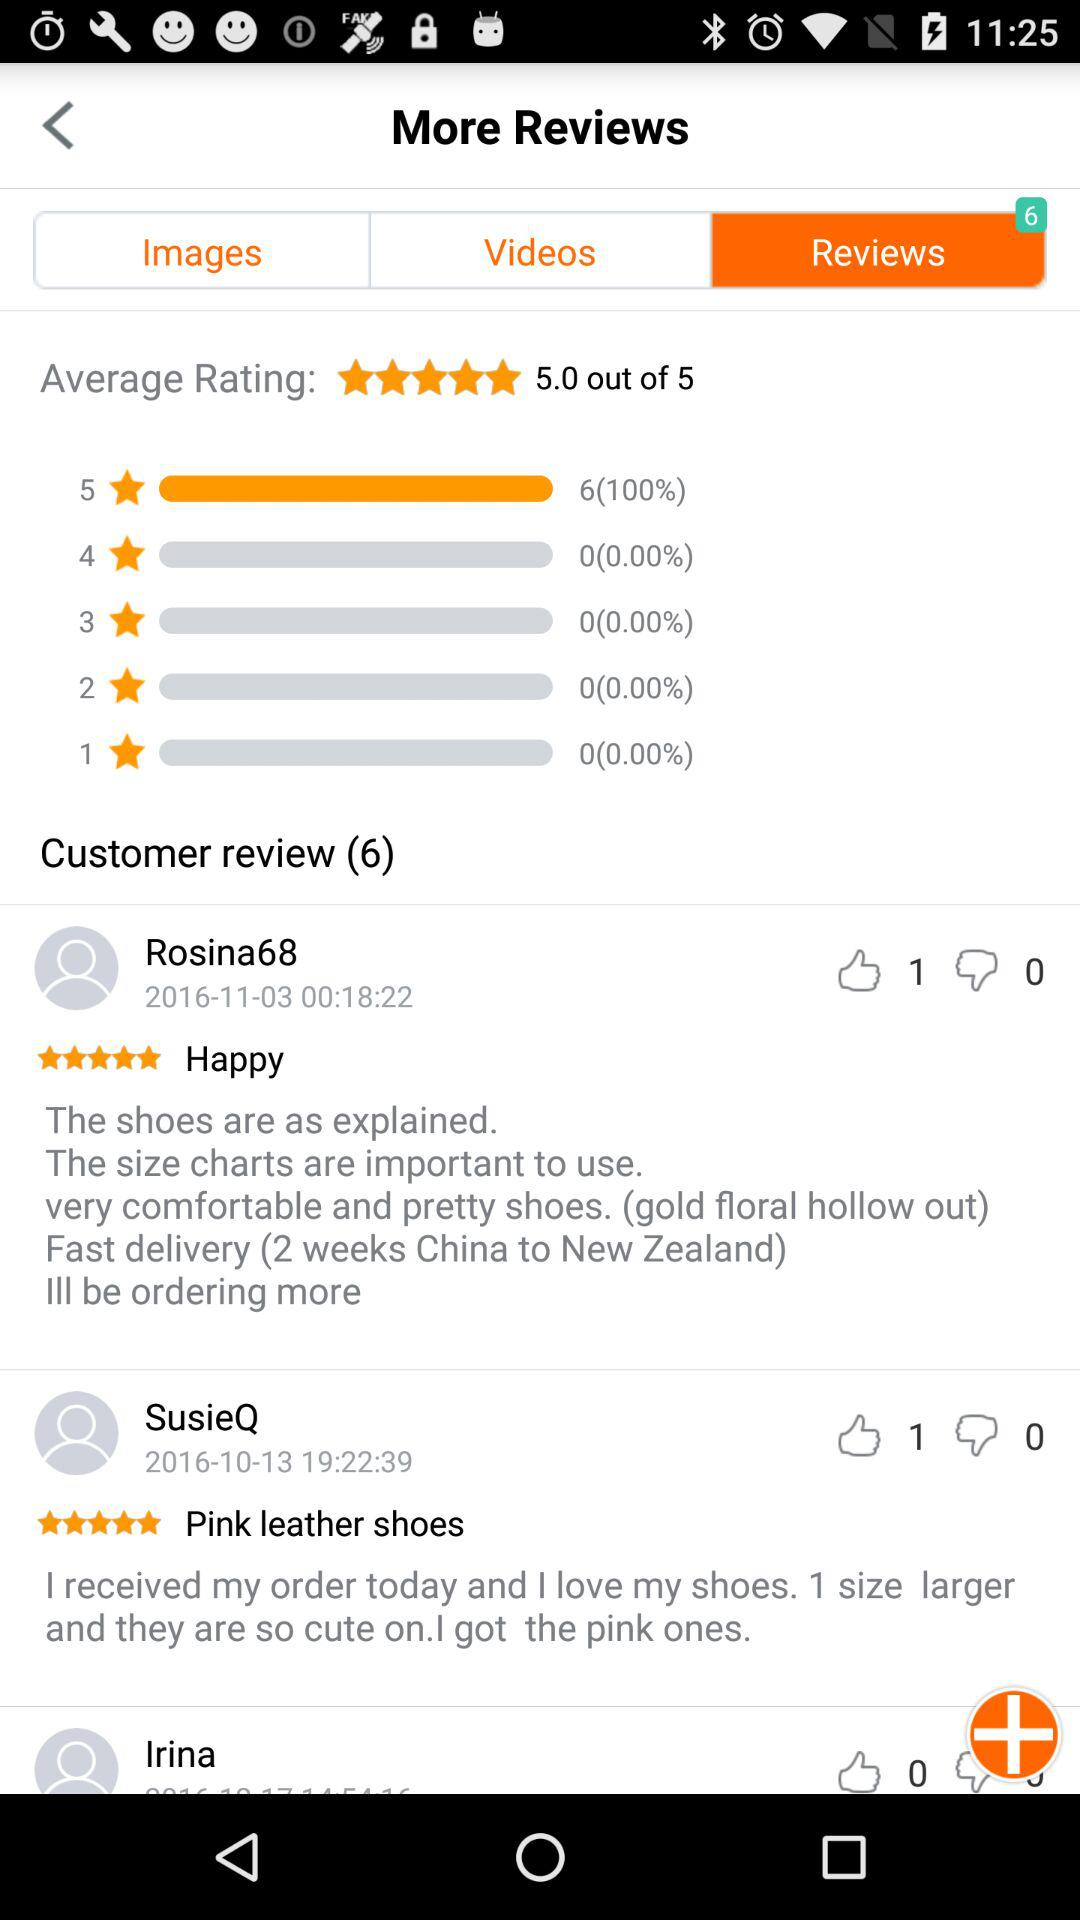How many likes are there for Irina? There are 0 likes for Irina. 